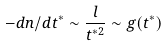<formula> <loc_0><loc_0><loc_500><loc_500>- d n / d t ^ { * } \sim \frac { l } { t ^ { * 2 } } \sim g ( t ^ { * } )</formula> 